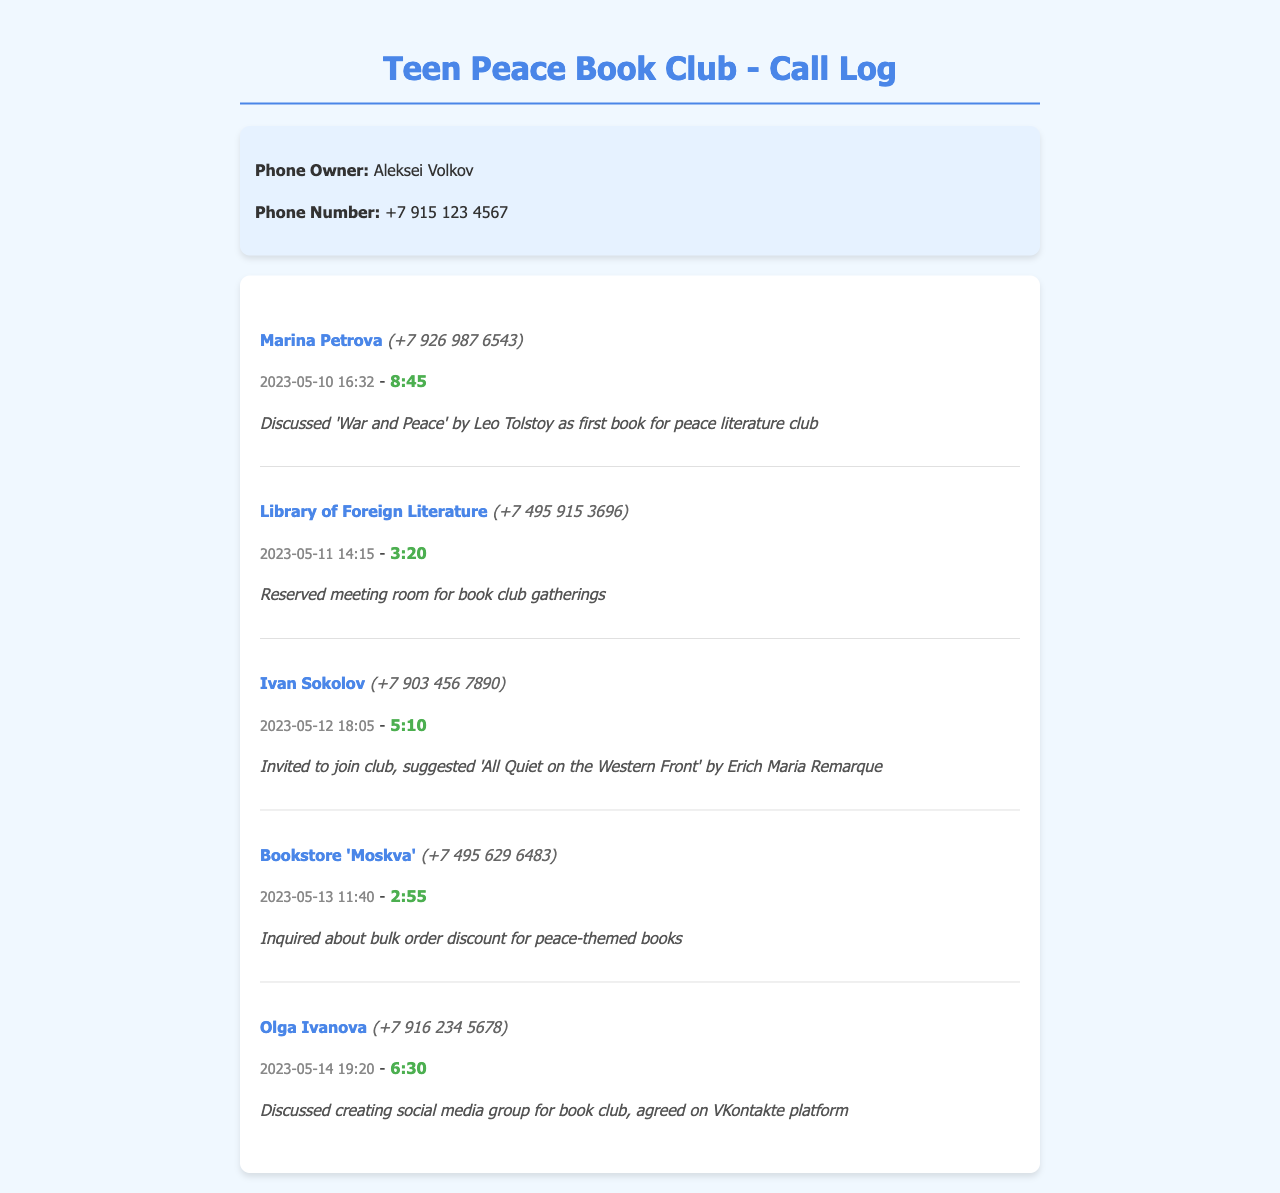What is the name of the phone owner? The document specifies that the owner of the phone is Aleksei Volkov.
Answer: Aleksei Volkov Who did Aleksei discuss the first book with? The call log mentions a conversation about the first book with Marina Petrova.
Answer: Marina Petrova What is the phone number of the Library of Foreign Literature? The document provides the contact number for the Library of Foreign Literature, which is +7 495 915 3696.
Answer: +7 495 915 3696 When was the meeting room reserved for the book club? According to the records, the room was reserved on May 11, 2023.
Answer: 2023-05-11 How long was the call with Ivan Sokolov? The duration of the call with Ivan Sokolov was 5 minutes and 10 seconds.
Answer: 5:10 Which book was suggested by Ivan Sokolov? The call log indicates that Ivan suggested the book 'All Quiet on the Western Front'.
Answer: All Quiet on the Western Front What was discussed in the call with Olga Ivanova? The notes state that a social media group for the book club was discussed during the call.
Answer: Social media group What platform was agreed upon for the social media group? The reference notes specify that the VKontakte platform was chosen for the social media group.
Answer: VKontakte How many calls are logged in the document? The call log includes a total of five entries.
Answer: Five 